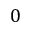Convert formula to latex. <formula><loc_0><loc_0><loc_500><loc_500>0</formula> 